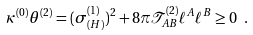<formula> <loc_0><loc_0><loc_500><loc_500>\kappa ^ { ( 0 ) } \theta ^ { ( 2 ) } = ( \sigma _ { ( H ) } ^ { ( 1 ) } ) ^ { 2 } + 8 \pi \mathcal { T } ^ { ( 2 ) } _ { A B } \ell ^ { A } \ell ^ { B } \geq 0 \ .</formula> 